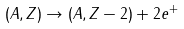<formula> <loc_0><loc_0><loc_500><loc_500>( A , Z ) \rightarrow ( A , Z - 2 ) + 2 e ^ { + }</formula> 